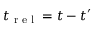Convert formula to latex. <formula><loc_0><loc_0><loc_500><loc_500>t _ { r e l } = t - t ^ { \prime }</formula> 